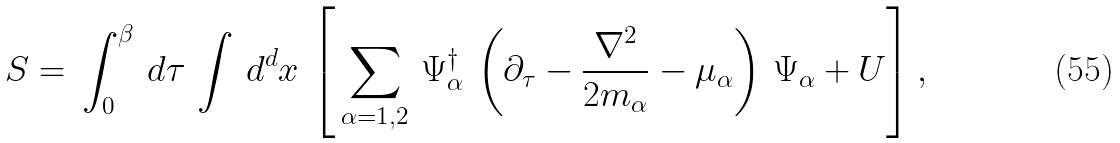<formula> <loc_0><loc_0><loc_500><loc_500>S = \, \int ^ { \beta } _ { 0 } \, d \tau \, \int \, d ^ { d } x \, \left [ \, \sum _ { \alpha = 1 , 2 } \, \Psi _ { \alpha } ^ { \dagger } \, \left ( \partial _ { \tau } - \frac { \nabla ^ { 2 } } { 2 m _ { \alpha } } - \mu _ { \alpha } \right ) \, \Psi _ { \alpha } + U \right ] ,</formula> 